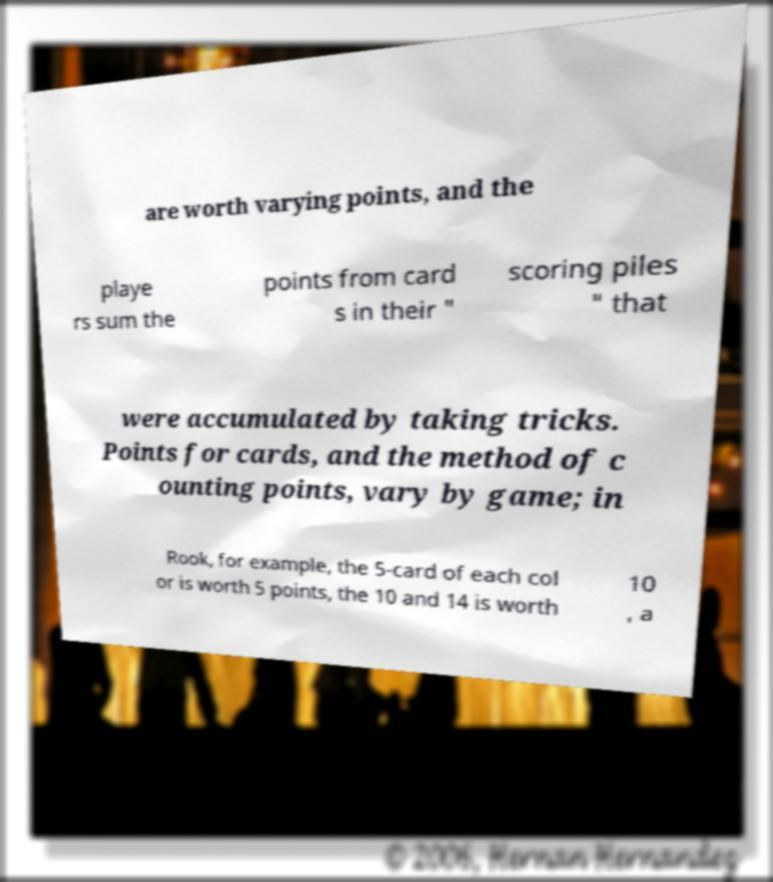Could you extract and type out the text from this image? are worth varying points, and the playe rs sum the points from card s in their " scoring piles " that were accumulated by taking tricks. Points for cards, and the method of c ounting points, vary by game; in Rook, for example, the 5-card of each col or is worth 5 points, the 10 and 14 is worth 10 , a 